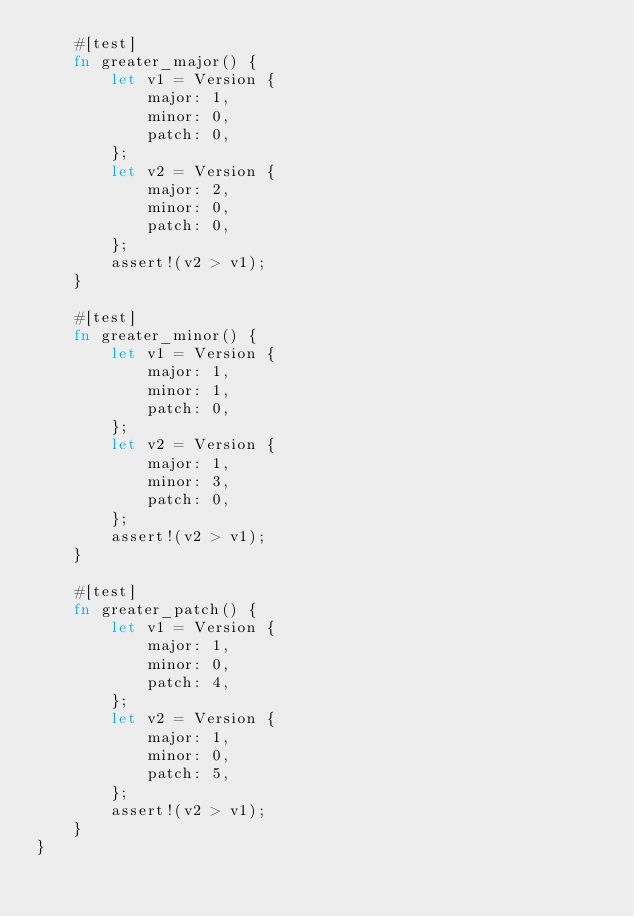Convert code to text. <code><loc_0><loc_0><loc_500><loc_500><_Rust_>    #[test]
    fn greater_major() {
        let v1 = Version {
            major: 1,
            minor: 0,
            patch: 0,
        };
        let v2 = Version {
            major: 2,
            minor: 0,
            patch: 0,
        };
        assert!(v2 > v1);
    }

    #[test]
    fn greater_minor() {
        let v1 = Version {
            major: 1,
            minor: 1,
            patch: 0,
        };
        let v2 = Version {
            major: 1,
            minor: 3,
            patch: 0,
        };
        assert!(v2 > v1);
    }

    #[test]
    fn greater_patch() {
        let v1 = Version {
            major: 1,
            minor: 0,
            patch: 4,
        };
        let v2 = Version {
            major: 1,
            minor: 0,
            patch: 5,
        };
        assert!(v2 > v1);
    }
}
</code> 